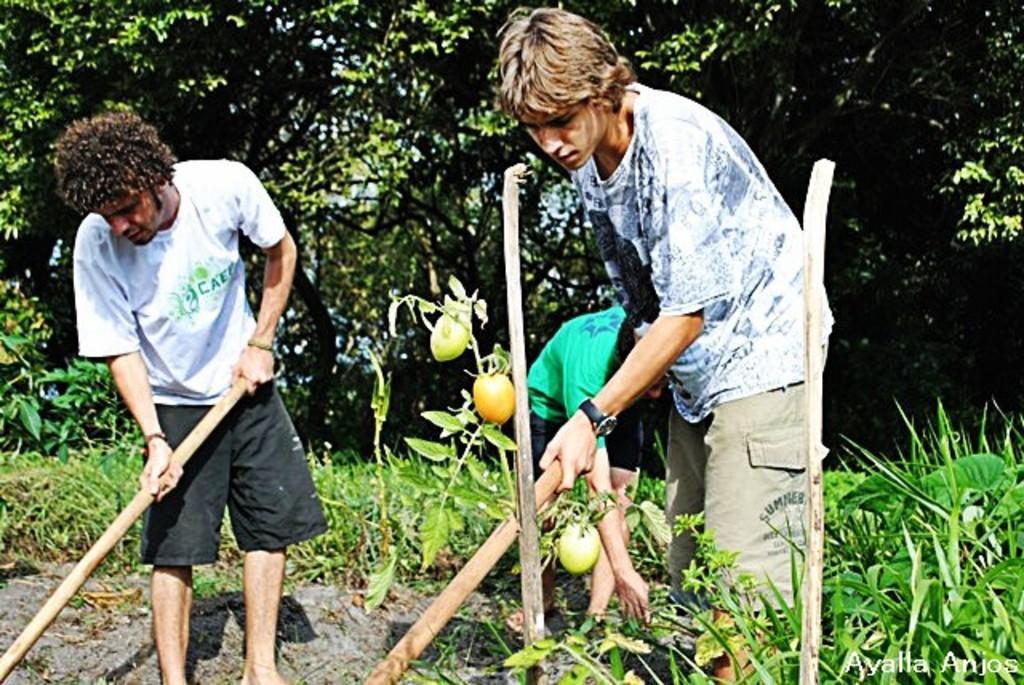In one or two sentences, can you explain what this image depicts? Here in this picture we can see two men standing on the ground, both of them are holding sticks in their hands and we can see the ground is fully covered with grass and we can also see plants and trees over there and we can see some fruits on plants and behind them also we can see another person present. 